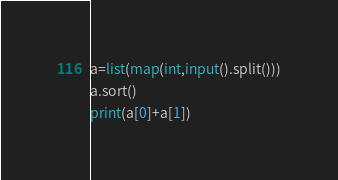Convert code to text. <code><loc_0><loc_0><loc_500><loc_500><_Python_>a=list(map(int,input().split()))
a.sort()
print(a[0]+a[1])</code> 